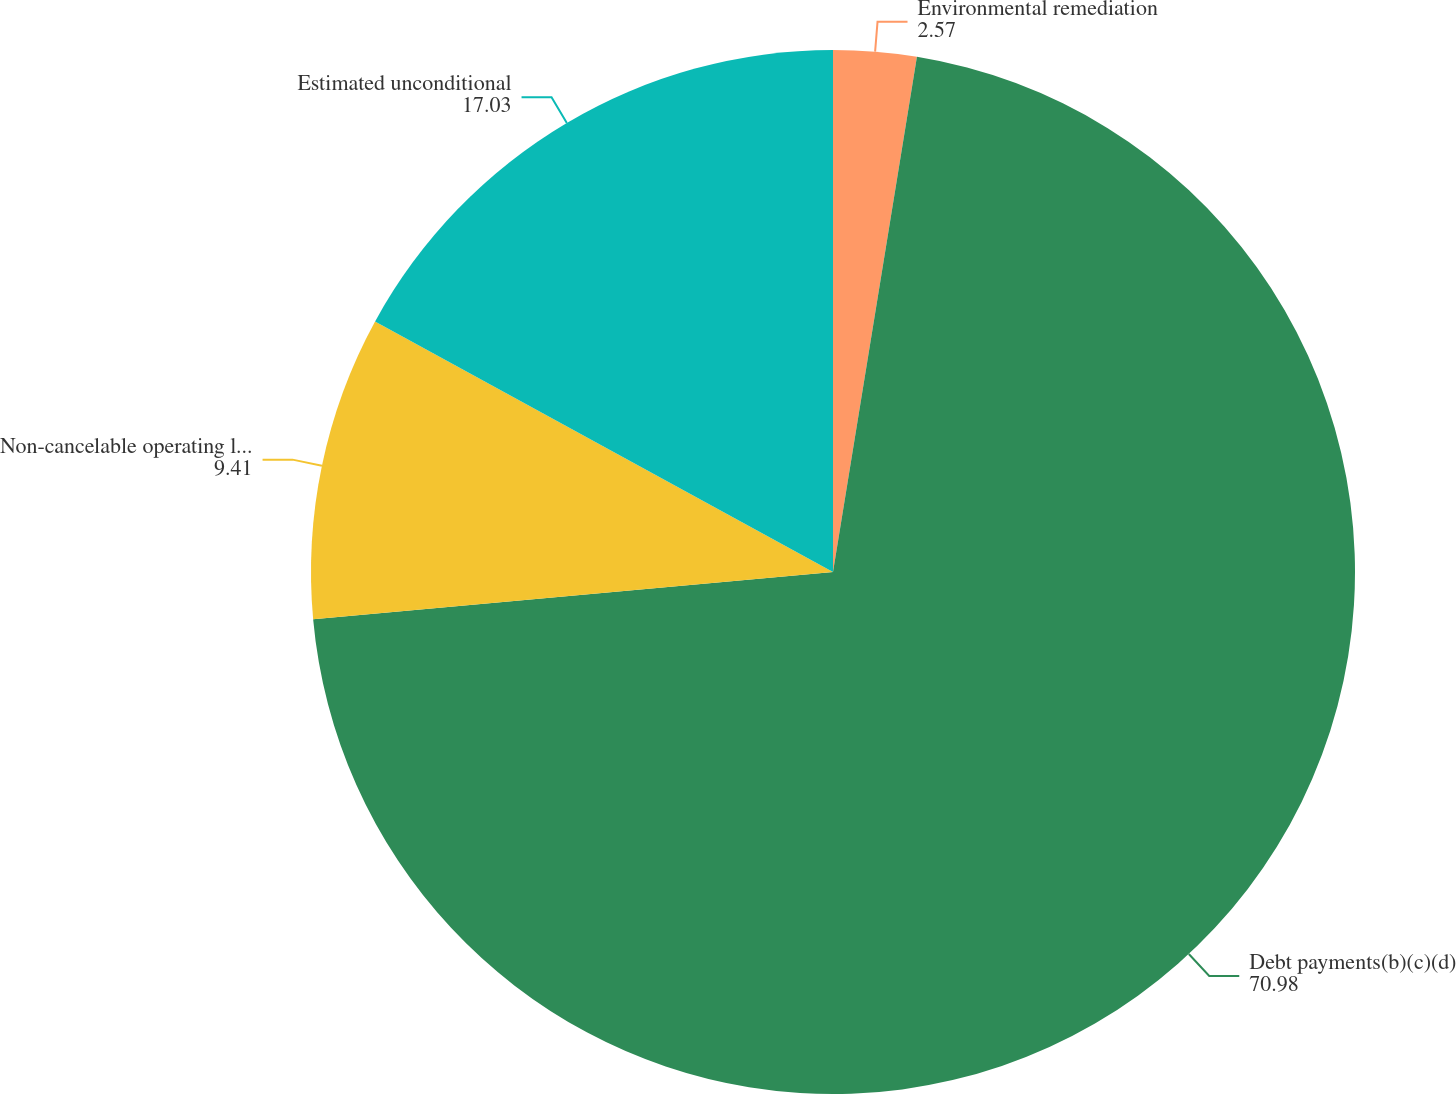<chart> <loc_0><loc_0><loc_500><loc_500><pie_chart><fcel>Environmental remediation<fcel>Debt payments(b)(c)(d)<fcel>Non-cancelable operating lease<fcel>Estimated unconditional<nl><fcel>2.57%<fcel>70.98%<fcel>9.41%<fcel>17.03%<nl></chart> 